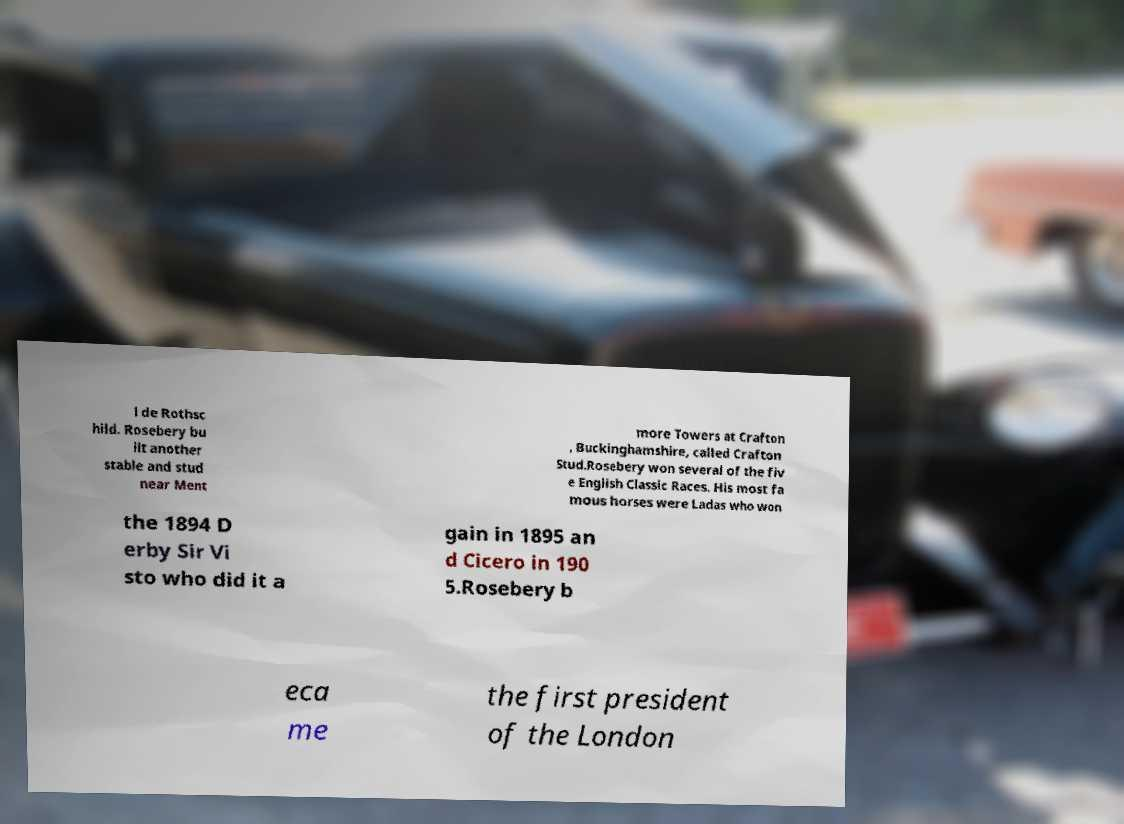Please read and relay the text visible in this image. What does it say? l de Rothsc hild. Rosebery bu ilt another stable and stud near Ment more Towers at Crafton , Buckinghamshire, called Crafton Stud.Rosebery won several of the fiv e English Classic Races. His most fa mous horses were Ladas who won the 1894 D erby Sir Vi sto who did it a gain in 1895 an d Cicero in 190 5.Rosebery b eca me the first president of the London 